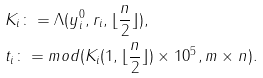Convert formula to latex. <formula><loc_0><loc_0><loc_500><loc_500>& K _ { i } \colon = \Lambda ( y ^ { 0 } _ { i } , r _ { i } , \lfloor \frac { n } { 2 } \rfloor ) , \\ & t _ { i } \colon = m o d ( K _ { i } ( 1 , \lfloor \frac { n } { 2 } \rfloor ) \times 1 0 ^ { 5 } , m \times n ) .</formula> 